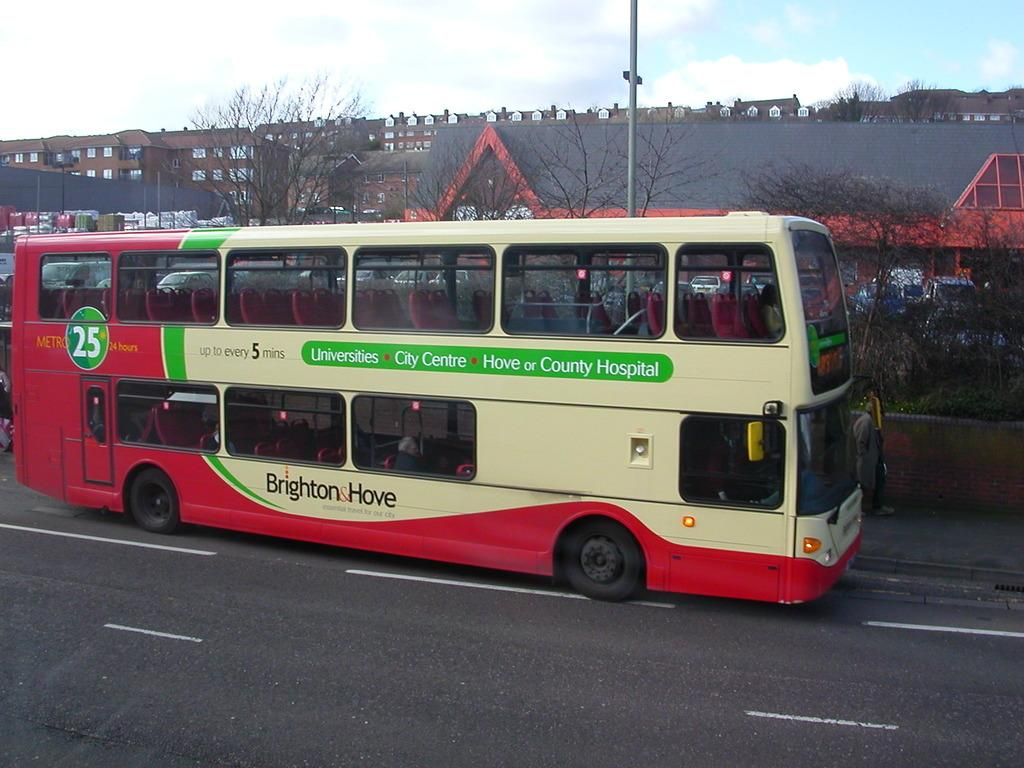<image>
Present a compact description of the photo's key features. Double decker bus that says "Up to every 5 mins" on the side. 